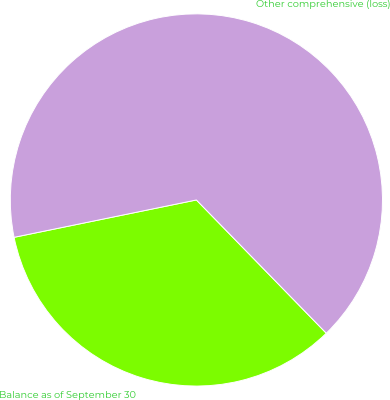Convert chart. <chart><loc_0><loc_0><loc_500><loc_500><pie_chart><fcel>Balance as of September 30<fcel>Other comprehensive (loss)<nl><fcel>34.08%<fcel>65.92%<nl></chart> 